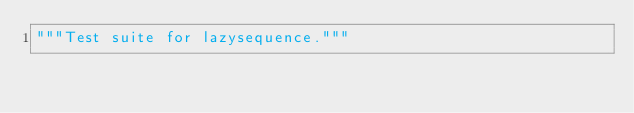Convert code to text. <code><loc_0><loc_0><loc_500><loc_500><_Python_>"""Test suite for lazysequence."""
</code> 